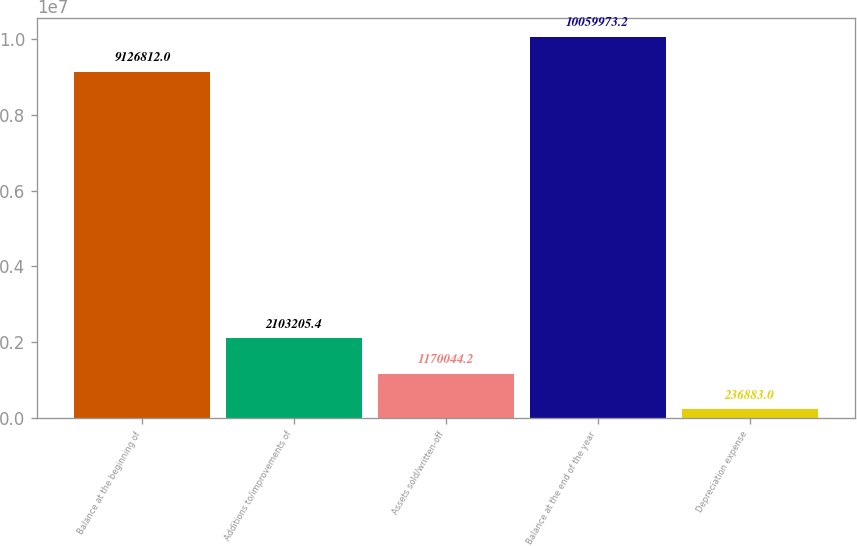Convert chart. <chart><loc_0><loc_0><loc_500><loc_500><bar_chart><fcel>Balance at the beginning of<fcel>Additions to/improvements of<fcel>Assets sold/written-off<fcel>Balance at the end of the year<fcel>Depreciation expense<nl><fcel>9.12681e+06<fcel>2.10321e+06<fcel>1.17004e+06<fcel>1.006e+07<fcel>236883<nl></chart> 